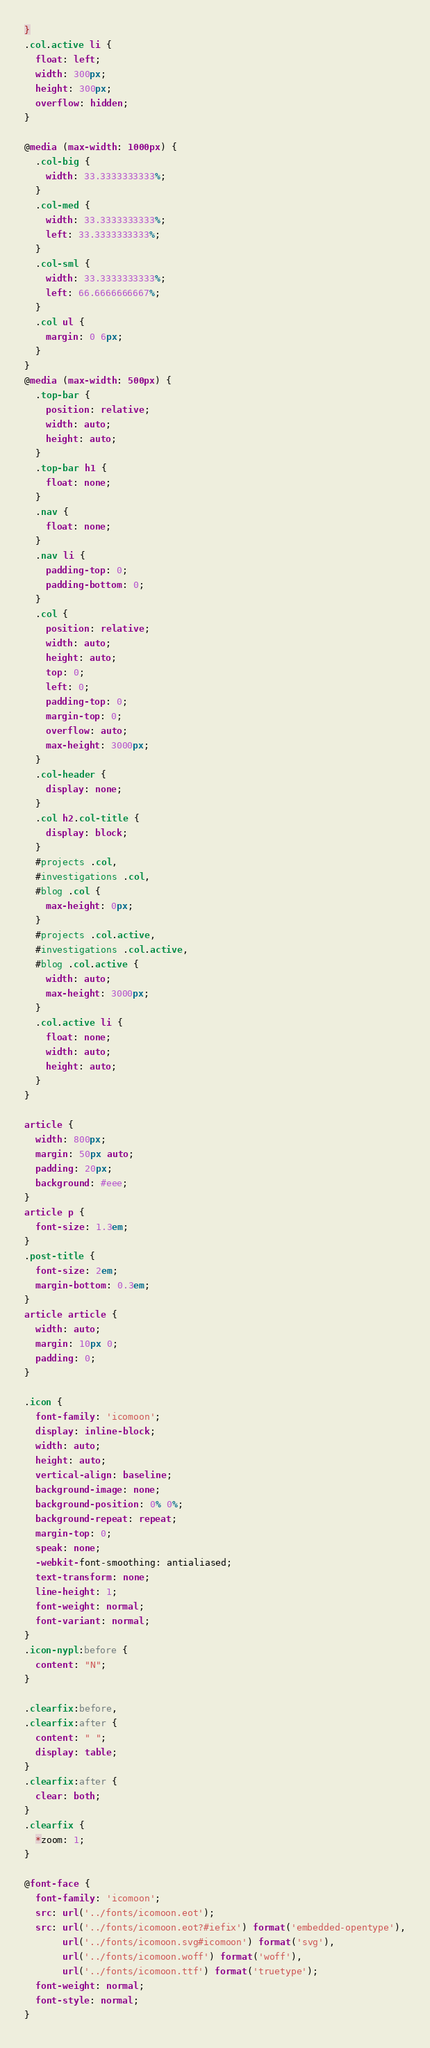<code> <loc_0><loc_0><loc_500><loc_500><_CSS_>}
.col.active li {
  float: left;
  width: 300px;
  height: 300px;
  overflow: hidden;
}

@media (max-width: 1000px) {
  .col-big {
    width: 33.3333333333%;
  }
  .col-med {
    width: 33.3333333333%;
    left: 33.3333333333%;
  }
  .col-sml {
    width: 33.3333333333%;
    left: 66.6666666667%;
  }
  .col ul {
    margin: 0 6px;
  }
}
@media (max-width: 500px) {
  .top-bar {
    position: relative;
    width: auto;
    height: auto;
  }
  .top-bar h1 {
    float: none;
  }
  .nav {
    float: none;
  }
  .nav li {
    padding-top: 0;
    padding-bottom: 0;
  }
  .col {    
    position: relative;
    width: auto;
    height: auto;
    top: 0;
    left: 0;
    padding-top: 0;
    margin-top: 0;
    overflow: auto;
    max-height: 3000px;
  }
  .col-header {
    display: none;
  }
  .col h2.col-title {
    display: block;
  }
  #projects .col,
  #investigations .col,
  #blog .col {
    max-height: 0px;
  }
  #projects .col.active,
  #investigations .col.active,
  #blog .col.active {
    width: auto;
    max-height: 3000px;
  }
  .col.active li {
    float: none;
    width: auto;
    height: auto;
  }
}

article {
  width: 800px;
  margin: 50px auto;
  padding: 20px;
  background: #eee;
}
article p {
  font-size: 1.3em;
}
.post-title {
  font-size: 2em;
  margin-bottom: 0.3em;
}
article article {
  width: auto;
  margin: 10px 0;
  padding: 0;
}

.icon {
  font-family: 'icomoon';
  display: inline-block;
  width: auto;
  height: auto;
  vertical-align: baseline;
  background-image: none;
  background-position: 0% 0%;
  background-repeat: repeat;
  margin-top: 0;
  speak: none;
  -webkit-font-smoothing: antialiased;
  text-transform: none;
  line-height: 1;
  font-weight: normal;
  font-variant: normal;
}
.icon-nypl:before {
  content: "N";
}

.clearfix:before,
.clearfix:after {
  content: " ";
  display: table;
}
.clearfix:after {
  clear: both;
}
.clearfix {
  *zoom: 1;
}

@font-face {
  font-family: 'icomoon';
  src: url('../fonts/icomoon.eot');
  src: url('../fonts/icomoon.eot?#iefix') format('embedded-opentype'),
       url('../fonts/icomoon.svg#icomoon') format('svg'),
       url('../fonts/icomoon.woff') format('woff'),
       url('../fonts/icomoon.ttf') format('truetype');
  font-weight: normal;
  font-style: normal;
}
</code> 